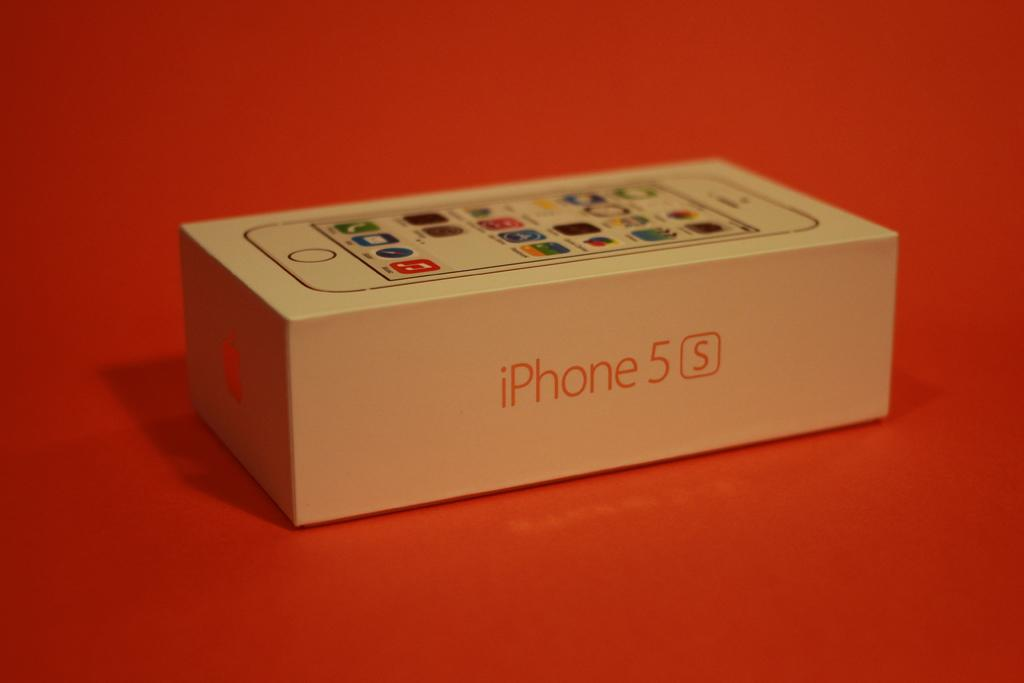<image>
Provide a brief description of the given image. A tan iPhone 5s box lays on an orange surface. 